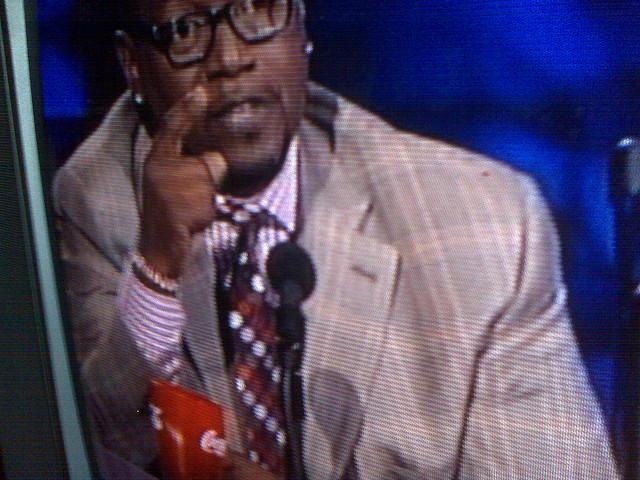What is the man drinking?
Answer briefly. Coke. Is he in a basement?
Short answer required. No. What is he talking on?
Keep it brief. Microphone. What is the man pointing to?
Be succinct. Contestant. Is this a real person?
Concise answer only. Yes. What color is the cup?
Be succinct. Red. Is this an image of a picture on TV?
Short answer required. Yes. 